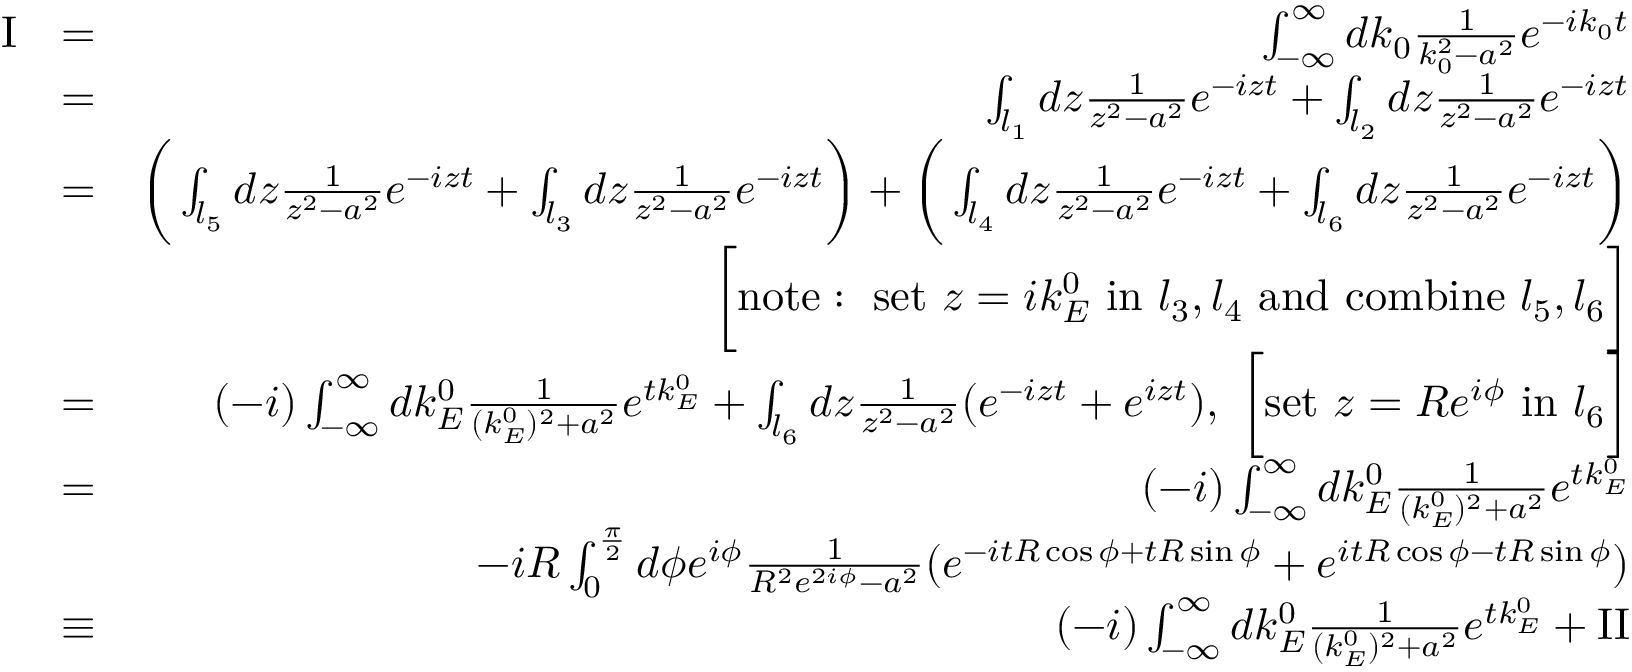<formula> <loc_0><loc_0><loc_500><loc_500>\begin{array} { r l r } { I } & { = } & { \int _ { - \infty } ^ { \infty } d k _ { 0 } \frac { 1 } { k _ { 0 } ^ { 2 } - a ^ { 2 } } e ^ { - i k _ { 0 } t } } \\ & { = } & { \int _ { l _ { 1 } } d z \frac { 1 } { z ^ { 2 } - a ^ { 2 } } e ^ { - i z t } + \int _ { l _ { 2 } } d z \frac { 1 } { z ^ { 2 } - a ^ { 2 } } e ^ { - i z t } } \\ & { = } & { \left ( \int _ { l _ { 5 } } d z \frac { 1 } { z ^ { 2 } - a ^ { 2 } } e ^ { - i z t } + \int _ { l _ { 3 } } d z \frac { 1 } { z ^ { 2 } - a ^ { 2 } } e ^ { - i z t } \right ) + \left ( \int _ { l _ { 4 } } d z \frac { 1 } { z ^ { 2 } - a ^ { 2 } } e ^ { - i z t } + \int _ { l _ { 6 } } d z \frac { 1 } { z ^ { 2 } - a ^ { 2 } } e ^ { - i z t } \right ) } \\ & { \left [ n o t e \colon s e t z = i k _ { E } ^ { 0 } i n l _ { 3 } , l _ { 4 } a n d c o m b i n e l _ { 5 } , l _ { 6 } \right ] } \\ & { = } & { ( - i ) \int _ { - \infty } ^ { \infty } d k _ { E } ^ { 0 } \frac { 1 } { ( k _ { E } ^ { 0 } ) ^ { 2 } + a ^ { 2 } } e ^ { t k _ { E } ^ { 0 } } + \int _ { l _ { 6 } } d z \frac { 1 } { z ^ { 2 } - a ^ { 2 } } ( e ^ { - i z t } + e ^ { i z t } ) , \ \left [ s e t z = R e ^ { i \phi } i n l _ { 6 } \right ] } \\ & { = } & { ( - i ) \int _ { - \infty } ^ { \infty } d k _ { E } ^ { 0 } \frac { 1 } { ( k _ { E } ^ { 0 } ) ^ { 2 } + a ^ { 2 } } e ^ { t k _ { E } ^ { 0 } } } \\ & { - i R \int _ { 0 } ^ { \frac { \pi } { 2 } } d \phi e ^ { i \phi } \frac { 1 } { R ^ { 2 } e ^ { 2 i \phi } - a ^ { 2 } } ( e ^ { - i t R \cos \phi + t R \sin \phi } + e ^ { i t R \cos \phi - t R \sin \phi } ) } \\ & { \equiv } & { ( - i ) \int _ { - \infty } ^ { \infty } d k _ { E } ^ { 0 } \frac { 1 } { ( k _ { E } ^ { 0 } ) ^ { 2 } + a ^ { 2 } } e ^ { t k _ { E } ^ { 0 } } + I I } \end{array}</formula> 